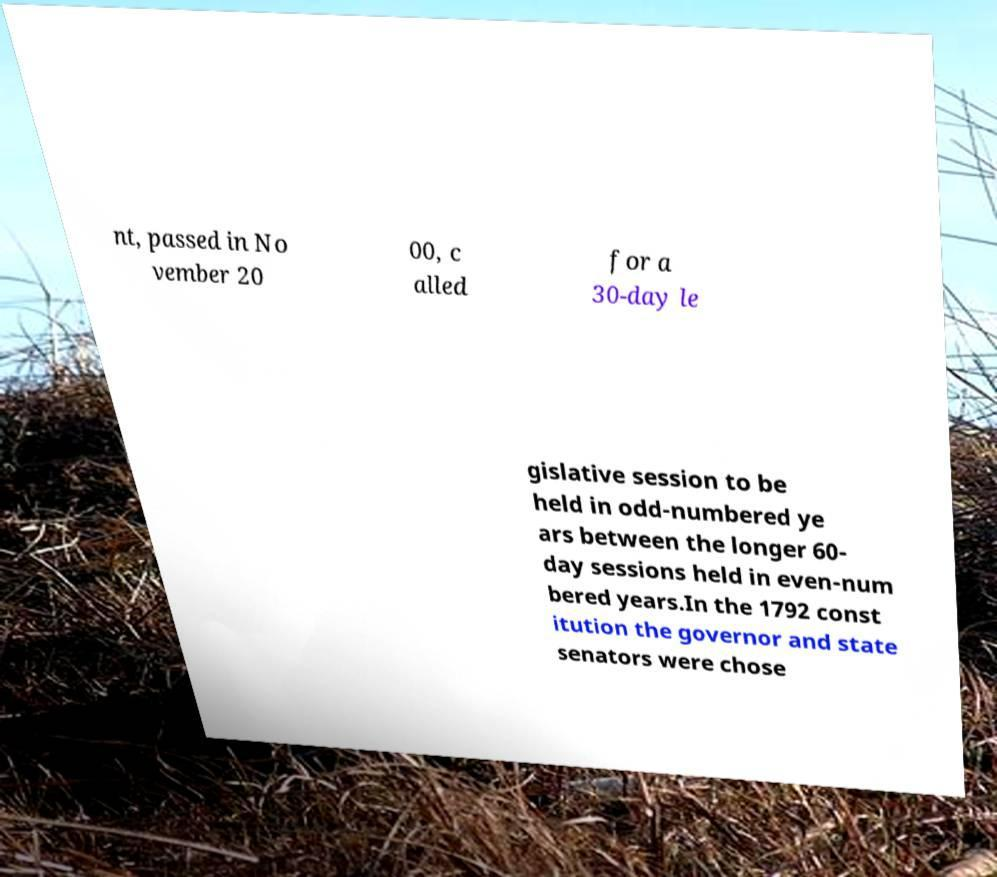Could you assist in decoding the text presented in this image and type it out clearly? nt, passed in No vember 20 00, c alled for a 30-day le gislative session to be held in odd-numbered ye ars between the longer 60- day sessions held in even-num bered years.In the 1792 const itution the governor and state senators were chose 